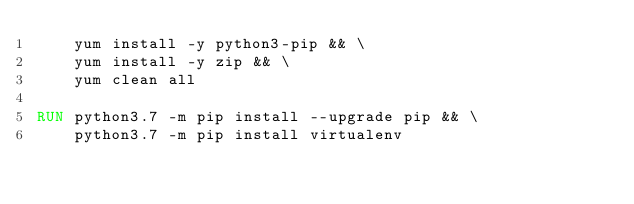<code> <loc_0><loc_0><loc_500><loc_500><_Dockerfile_>    yum install -y python3-pip && \
    yum install -y zip && \
    yum clean all

RUN python3.7 -m pip install --upgrade pip && \
    python3.7 -m pip install virtualenv</code> 